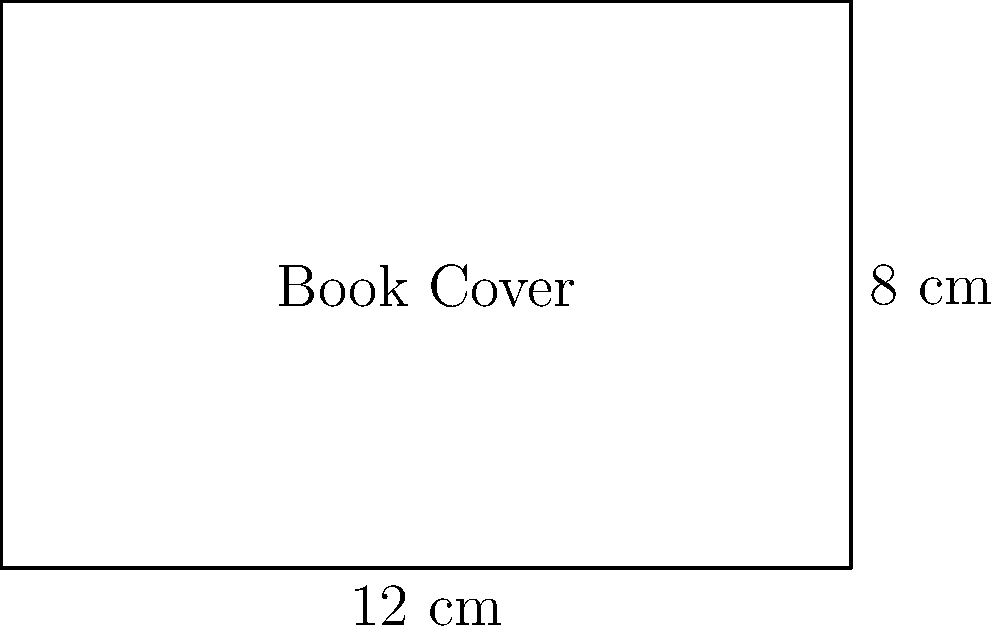For your upcoming book launch, you've designed a rectangular book cover inspired by your favorite musician's album art. The cover measures 12 cm in width and 8 cm in height. What is the perimeter of the book cover? Let's approach this step-by-step:

1) The perimeter of a rectangle is the sum of all its sides.

2) The formula for the perimeter of a rectangle is:
   $$P = 2l + 2w$$
   where $P$ is the perimeter, $l$ is the length (or height in this case), and $w$ is the width.

3) We are given:
   Width ($w$) = 12 cm
   Height ($l$) = 8 cm

4) Let's substitute these values into our formula:
   $$P = 2(8) + 2(12)$$

5) Now let's calculate:
   $$P = 16 + 24 = 40$$

Therefore, the perimeter of the book cover is 40 cm.
Answer: 40 cm 